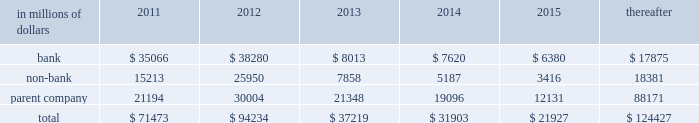Cgmhi has committed long-term financing facilities with unaffiliated banks .
At december 31 , 2010 , cgmhi had drawn down the full $ 900 million available under these facilities , of which $ 150 million is guaranteed by citigroup .
Generally , a bank can terminate these facilities by giving cgmhi one-year prior notice .
The company issues both fixed and variable rate debt in a range of currencies .
It uses derivative contracts , primarily interest rate swaps , to effectively convert a portion of its fixed rate debt to variable rate debt and variable rate debt to fixed rate debt .
The maturity structure of the derivatives generally corresponds to the maturity structure of the debt being hedged .
In addition , the company uses other derivative contracts to manage the foreign exchange impact of certain debt issuances .
At december 31 , 2010 , the company 2019s overall weighted average interest rate for long-term debt was 3.53% ( 3.53 % ) on a contractual basis and 2.78% ( 2.78 % ) including the effects of derivative contracts .
Aggregate annual maturities of long-term debt obligations ( based on final maturity dates ) including trust preferred securities are as follows : long-term debt at december 31 , 2010 and december 31 , 2009 includes $ 18131 million and $ 19345 million , respectively , of junior subordinated debt .
The company formed statutory business trusts under the laws of the state of delaware .
The trusts exist for the exclusive purposes of ( i ) issuing trust securities representing undivided beneficial interests in the assets of the trust ; ( ii ) investing the gross proceeds of the trust securities in junior subordinated deferrable interest debentures ( subordinated debentures ) of its parent ; and ( iii ) engaging in only those activities necessary or incidental thereto .
Upon approval from the federal reserve , citigroup has the right to redeem these securities .
Citigroup has contractually agreed not to redeem or purchase ( i ) the 6.50% ( 6.50 % ) enhanced trust preferred securities of citigroup capital xv before september 15 , 2056 , ( ii ) the 6.45% ( 6.45 % ) enhanced trust preferred securities of citigroup capital xvi before december 31 , 2046 , ( iii ) the 6.35% ( 6.35 % ) enhanced trust preferred securities of citigroup capital xvii before march 15 , 2057 , ( iv ) the 6.829% ( 6.829 % ) fixed rate/floating rate enhanced trust preferred securities of citigroup capital xviii before june 28 , 2047 , ( v ) the 7.250% ( 7.250 % ) enhanced trust preferred securities of citigroup capital xix before august 15 , 2047 , ( vi ) the 7.875% ( 7.875 % ) enhanced trust preferred securities of citigroup capital xx before december 15 , 2067 , and ( vii ) the 8.300% ( 8.300 % ) fixed rate/floating rate enhanced trust preferred securities of citigroup capital xxi before december 21 , 2067 , unless certain conditions , described in exhibit 4.03 to citigroup 2019s current report on form 8-k filed on september 18 , 2006 , in exhibit 4.02 to citigroup 2019s current report on form 8-k filed on november 28 , 2006 , in exhibit 4.02 to citigroup 2019s current report on form 8-k filed on march 8 , 2007 , in exhibit 4.02 to citigroup 2019s current report on form 8-k filed on july 2 , 2007 , in exhibit 4.02 to citigroup 2019s current report on form 8-k filed on august 17 , 2007 , in exhibit 4.2 to citigroup 2019s current report on form 8-k filed on november 27 , 2007 , and in exhibit 4.2 to citigroup 2019s current report on form 8-k filed on december 21 , 2007 , respectively , are met .
These agreements are for the benefit of the holders of citigroup 2019s 6.00% ( 6.00 % ) junior subordinated deferrable interest debentures due 2034 .
Citigroup owns all of the voting securities of these subsidiary trusts .
These subsidiary trusts have no assets , operations , revenues or cash flows other than those related to the issuance , administration , and repayment of the subsidiary trusts and the subsidiary trusts 2019 common securities .
These subsidiary trusts 2019 obligations are fully and unconditionally guaranteed by citigroup. .

In 2011 what was the percent of the subsidiary trusts 2019 obligations guaranteed by citigroup attributable to the bank? 
Computations: (35066 / 71473)
Answer: 0.49062. 